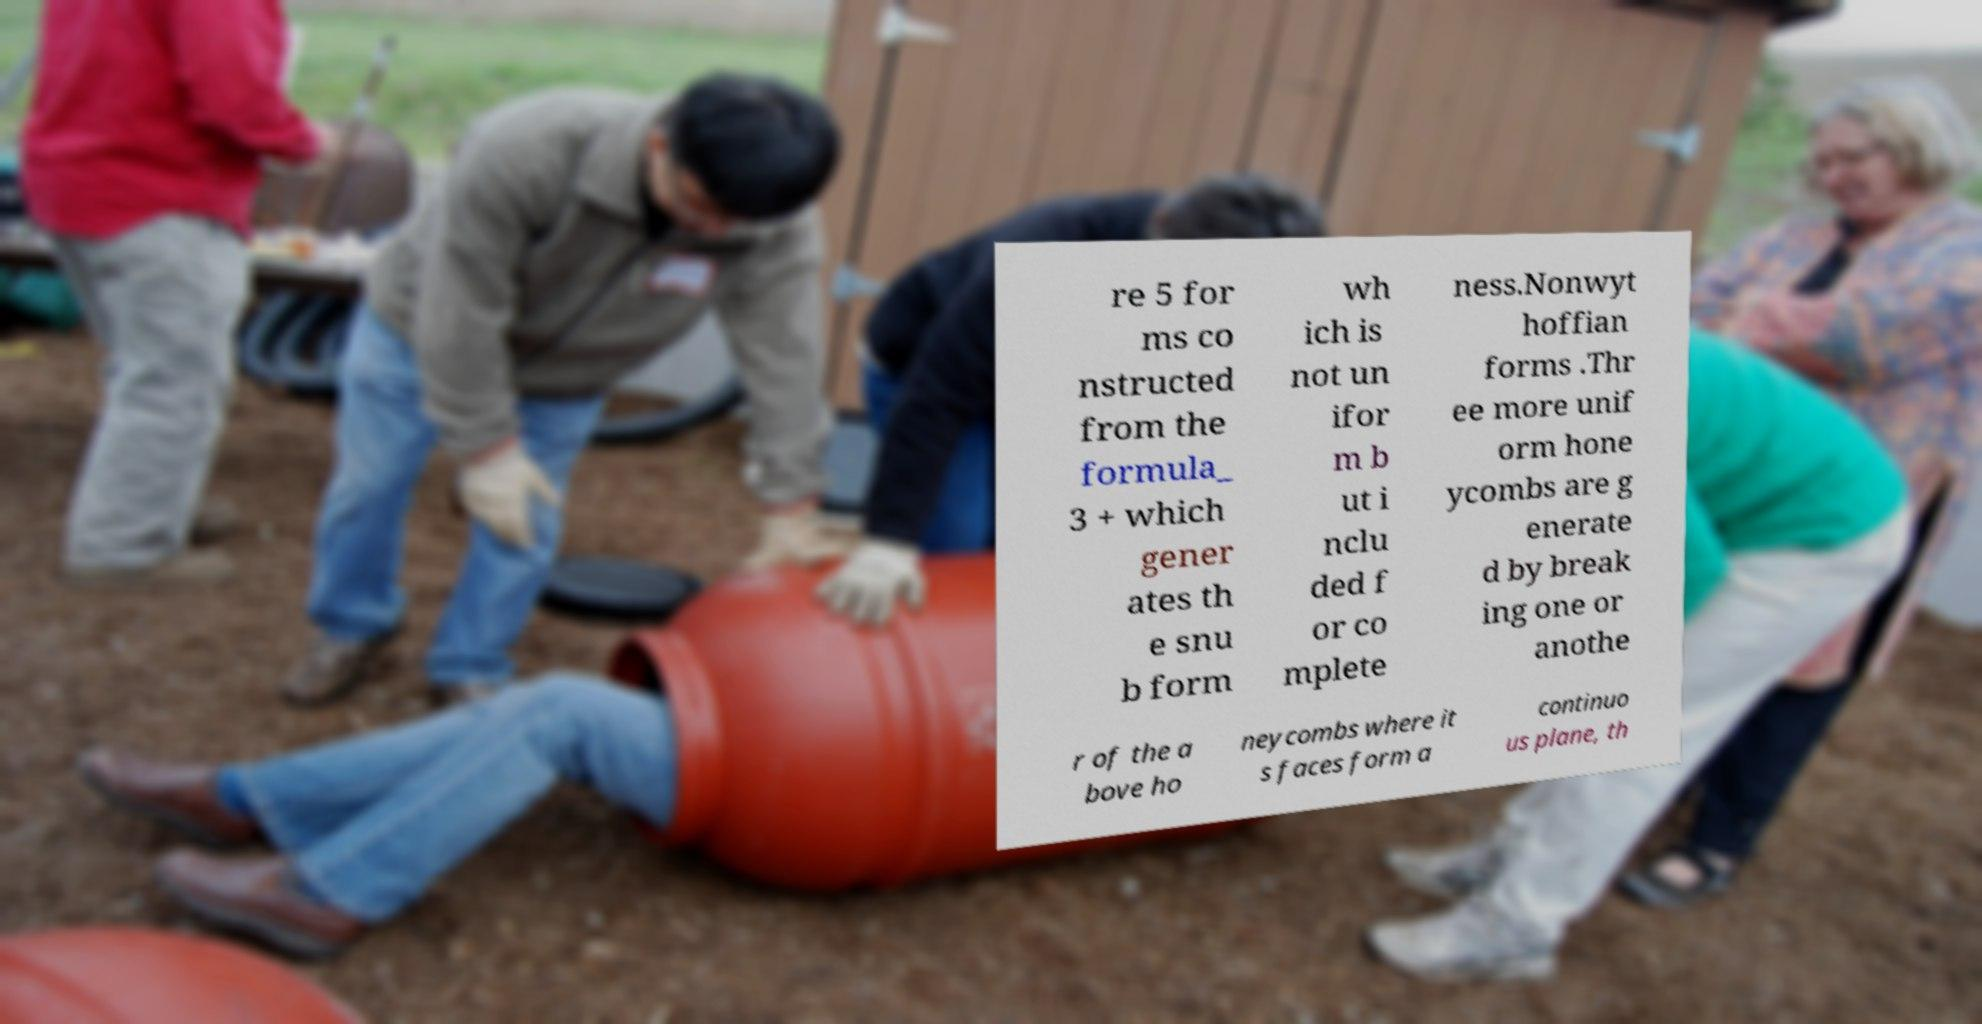Could you assist in decoding the text presented in this image and type it out clearly? re 5 for ms co nstructed from the formula_ 3 + which gener ates th e snu b form wh ich is not un ifor m b ut i nclu ded f or co mplete ness.Nonwyt hoffian forms .Thr ee more unif orm hone ycombs are g enerate d by break ing one or anothe r of the a bove ho neycombs where it s faces form a continuo us plane, th 